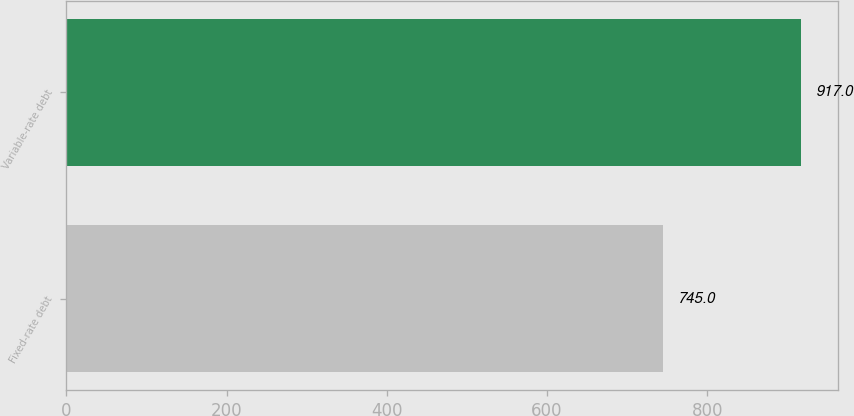<chart> <loc_0><loc_0><loc_500><loc_500><bar_chart><fcel>Fixed-rate debt<fcel>Variable-rate debt<nl><fcel>745<fcel>917<nl></chart> 